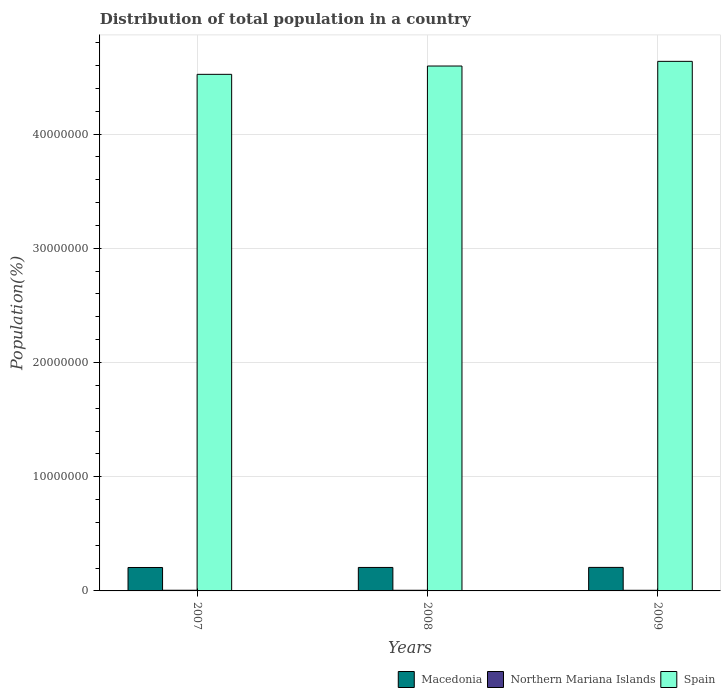How many different coloured bars are there?
Make the answer very short. 3. How many groups of bars are there?
Ensure brevity in your answer.  3. Are the number of bars on each tick of the X-axis equal?
Your answer should be compact. Yes. How many bars are there on the 2nd tick from the left?
Your response must be concise. 3. How many bars are there on the 3rd tick from the right?
Your answer should be very brief. 3. What is the label of the 3rd group of bars from the left?
Your response must be concise. 2009. In how many cases, is the number of bars for a given year not equal to the number of legend labels?
Give a very brief answer. 0. What is the population of in Spain in 2009?
Give a very brief answer. 4.64e+07. Across all years, what is the maximum population of in Macedonia?
Make the answer very short. 2.06e+06. Across all years, what is the minimum population of in Northern Mariana Islands?
Keep it short and to the point. 5.53e+04. In which year was the population of in Spain maximum?
Your response must be concise. 2009. What is the total population of in Northern Mariana Islands in the graph?
Provide a short and direct response. 1.72e+05. What is the difference between the population of in Spain in 2008 and that in 2009?
Ensure brevity in your answer.  -4.09e+05. What is the difference between the population of in Macedonia in 2008 and the population of in Spain in 2009?
Provide a succinct answer. -4.43e+07. What is the average population of in Spain per year?
Keep it short and to the point. 4.58e+07. In the year 2007, what is the difference between the population of in Northern Mariana Islands and population of in Spain?
Your answer should be very brief. -4.52e+07. In how many years, is the population of in Macedonia greater than 40000000 %?
Ensure brevity in your answer.  0. What is the ratio of the population of in Spain in 2007 to that in 2009?
Your response must be concise. 0.98. Is the population of in Macedonia in 2007 less than that in 2009?
Your answer should be compact. Yes. Is the difference between the population of in Northern Mariana Islands in 2007 and 2009 greater than the difference between the population of in Spain in 2007 and 2009?
Provide a succinct answer. Yes. What is the difference between the highest and the second highest population of in Spain?
Give a very brief answer. 4.09e+05. What is the difference between the highest and the lowest population of in Macedonia?
Ensure brevity in your answer.  7493. In how many years, is the population of in Spain greater than the average population of in Spain taken over all years?
Your answer should be compact. 2. Is the sum of the population of in Macedonia in 2008 and 2009 greater than the maximum population of in Northern Mariana Islands across all years?
Provide a short and direct response. Yes. What does the 1st bar from the left in 2007 represents?
Give a very brief answer. Macedonia. What does the 3rd bar from the right in 2007 represents?
Ensure brevity in your answer.  Macedonia. Is it the case that in every year, the sum of the population of in Macedonia and population of in Spain is greater than the population of in Northern Mariana Islands?
Make the answer very short. Yes. Are all the bars in the graph horizontal?
Ensure brevity in your answer.  No. What is the difference between two consecutive major ticks on the Y-axis?
Offer a very short reply. 1.00e+07. Are the values on the major ticks of Y-axis written in scientific E-notation?
Provide a short and direct response. No. Does the graph contain grids?
Give a very brief answer. Yes. Where does the legend appear in the graph?
Offer a terse response. Bottom right. How many legend labels are there?
Ensure brevity in your answer.  3. How are the legend labels stacked?
Ensure brevity in your answer.  Horizontal. What is the title of the graph?
Make the answer very short. Distribution of total population in a country. Does "Dominican Republic" appear as one of the legend labels in the graph?
Ensure brevity in your answer.  No. What is the label or title of the X-axis?
Provide a short and direct response. Years. What is the label or title of the Y-axis?
Give a very brief answer. Population(%). What is the Population(%) in Macedonia in 2007?
Make the answer very short. 2.05e+06. What is the Population(%) of Northern Mariana Islands in 2007?
Provide a short and direct response. 5.98e+04. What is the Population(%) of Spain in 2007?
Provide a short and direct response. 4.52e+07. What is the Population(%) of Macedonia in 2008?
Provide a short and direct response. 2.06e+06. What is the Population(%) in Northern Mariana Islands in 2008?
Ensure brevity in your answer.  5.73e+04. What is the Population(%) in Spain in 2008?
Give a very brief answer. 4.60e+07. What is the Population(%) of Macedonia in 2009?
Make the answer very short. 2.06e+06. What is the Population(%) of Northern Mariana Islands in 2009?
Your answer should be compact. 5.53e+04. What is the Population(%) of Spain in 2009?
Give a very brief answer. 4.64e+07. Across all years, what is the maximum Population(%) in Macedonia?
Keep it short and to the point. 2.06e+06. Across all years, what is the maximum Population(%) in Northern Mariana Islands?
Your response must be concise. 5.98e+04. Across all years, what is the maximum Population(%) in Spain?
Keep it short and to the point. 4.64e+07. Across all years, what is the minimum Population(%) of Macedonia?
Ensure brevity in your answer.  2.05e+06. Across all years, what is the minimum Population(%) of Northern Mariana Islands?
Provide a succinct answer. 5.53e+04. Across all years, what is the minimum Population(%) in Spain?
Make the answer very short. 4.52e+07. What is the total Population(%) of Macedonia in the graph?
Ensure brevity in your answer.  6.17e+06. What is the total Population(%) of Northern Mariana Islands in the graph?
Offer a terse response. 1.72e+05. What is the total Population(%) in Spain in the graph?
Provide a short and direct response. 1.38e+08. What is the difference between the Population(%) of Macedonia in 2007 and that in 2008?
Keep it short and to the point. -3839. What is the difference between the Population(%) of Northern Mariana Islands in 2007 and that in 2008?
Your answer should be compact. 2448. What is the difference between the Population(%) of Spain in 2007 and that in 2008?
Make the answer very short. -7.27e+05. What is the difference between the Population(%) of Macedonia in 2007 and that in 2009?
Your answer should be compact. -7493. What is the difference between the Population(%) in Northern Mariana Islands in 2007 and that in 2009?
Your answer should be compact. 4515. What is the difference between the Population(%) in Spain in 2007 and that in 2009?
Offer a terse response. -1.14e+06. What is the difference between the Population(%) of Macedonia in 2008 and that in 2009?
Provide a short and direct response. -3654. What is the difference between the Population(%) of Northern Mariana Islands in 2008 and that in 2009?
Your answer should be compact. 2067. What is the difference between the Population(%) of Spain in 2008 and that in 2009?
Your answer should be compact. -4.09e+05. What is the difference between the Population(%) of Macedonia in 2007 and the Population(%) of Northern Mariana Islands in 2008?
Offer a very short reply. 1.99e+06. What is the difference between the Population(%) of Macedonia in 2007 and the Population(%) of Spain in 2008?
Give a very brief answer. -4.39e+07. What is the difference between the Population(%) of Northern Mariana Islands in 2007 and the Population(%) of Spain in 2008?
Offer a terse response. -4.59e+07. What is the difference between the Population(%) of Macedonia in 2007 and the Population(%) of Northern Mariana Islands in 2009?
Ensure brevity in your answer.  2.00e+06. What is the difference between the Population(%) of Macedonia in 2007 and the Population(%) of Spain in 2009?
Your response must be concise. -4.43e+07. What is the difference between the Population(%) in Northern Mariana Islands in 2007 and the Population(%) in Spain in 2009?
Make the answer very short. -4.63e+07. What is the difference between the Population(%) in Macedonia in 2008 and the Population(%) in Northern Mariana Islands in 2009?
Give a very brief answer. 2.00e+06. What is the difference between the Population(%) in Macedonia in 2008 and the Population(%) in Spain in 2009?
Ensure brevity in your answer.  -4.43e+07. What is the difference between the Population(%) in Northern Mariana Islands in 2008 and the Population(%) in Spain in 2009?
Offer a very short reply. -4.63e+07. What is the average Population(%) of Macedonia per year?
Provide a short and direct response. 2.06e+06. What is the average Population(%) in Northern Mariana Islands per year?
Provide a succinct answer. 5.75e+04. What is the average Population(%) in Spain per year?
Offer a terse response. 4.58e+07. In the year 2007, what is the difference between the Population(%) in Macedonia and Population(%) in Northern Mariana Islands?
Provide a short and direct response. 1.99e+06. In the year 2007, what is the difference between the Population(%) in Macedonia and Population(%) in Spain?
Your answer should be very brief. -4.32e+07. In the year 2007, what is the difference between the Population(%) in Northern Mariana Islands and Population(%) in Spain?
Your answer should be very brief. -4.52e+07. In the year 2008, what is the difference between the Population(%) in Macedonia and Population(%) in Northern Mariana Islands?
Keep it short and to the point. 2.00e+06. In the year 2008, what is the difference between the Population(%) in Macedonia and Population(%) in Spain?
Provide a succinct answer. -4.39e+07. In the year 2008, what is the difference between the Population(%) of Northern Mariana Islands and Population(%) of Spain?
Your response must be concise. -4.59e+07. In the year 2009, what is the difference between the Population(%) in Macedonia and Population(%) in Northern Mariana Islands?
Provide a succinct answer. 2.00e+06. In the year 2009, what is the difference between the Population(%) in Macedonia and Population(%) in Spain?
Offer a very short reply. -4.43e+07. In the year 2009, what is the difference between the Population(%) in Northern Mariana Islands and Population(%) in Spain?
Offer a very short reply. -4.63e+07. What is the ratio of the Population(%) in Macedonia in 2007 to that in 2008?
Keep it short and to the point. 1. What is the ratio of the Population(%) in Northern Mariana Islands in 2007 to that in 2008?
Offer a terse response. 1.04. What is the ratio of the Population(%) of Spain in 2007 to that in 2008?
Offer a very short reply. 0.98. What is the ratio of the Population(%) in Macedonia in 2007 to that in 2009?
Your answer should be compact. 1. What is the ratio of the Population(%) of Northern Mariana Islands in 2007 to that in 2009?
Provide a succinct answer. 1.08. What is the ratio of the Population(%) in Spain in 2007 to that in 2009?
Ensure brevity in your answer.  0.98. What is the ratio of the Population(%) in Macedonia in 2008 to that in 2009?
Your answer should be compact. 1. What is the ratio of the Population(%) in Northern Mariana Islands in 2008 to that in 2009?
Your answer should be very brief. 1.04. What is the ratio of the Population(%) of Spain in 2008 to that in 2009?
Offer a very short reply. 0.99. What is the difference between the highest and the second highest Population(%) in Macedonia?
Your answer should be very brief. 3654. What is the difference between the highest and the second highest Population(%) in Northern Mariana Islands?
Provide a short and direct response. 2448. What is the difference between the highest and the second highest Population(%) of Spain?
Provide a short and direct response. 4.09e+05. What is the difference between the highest and the lowest Population(%) in Macedonia?
Provide a short and direct response. 7493. What is the difference between the highest and the lowest Population(%) in Northern Mariana Islands?
Offer a terse response. 4515. What is the difference between the highest and the lowest Population(%) in Spain?
Ensure brevity in your answer.  1.14e+06. 